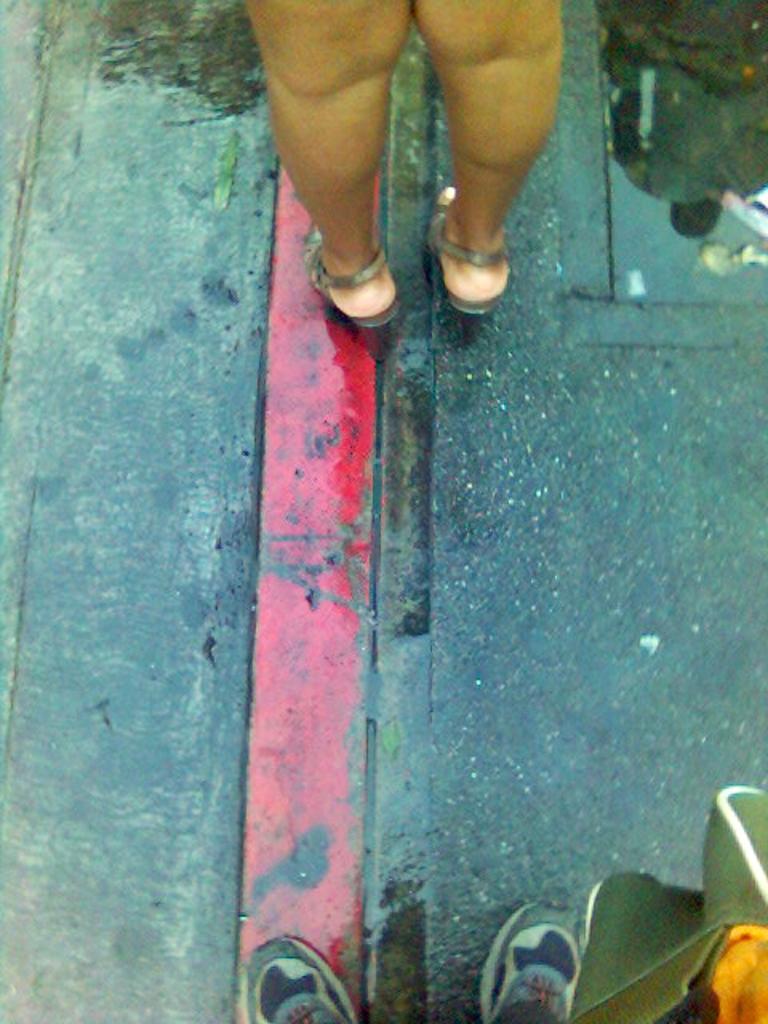Can you describe this image briefly? In this picture we can see legs of people on the road and we can see reflection of a person on the road. 